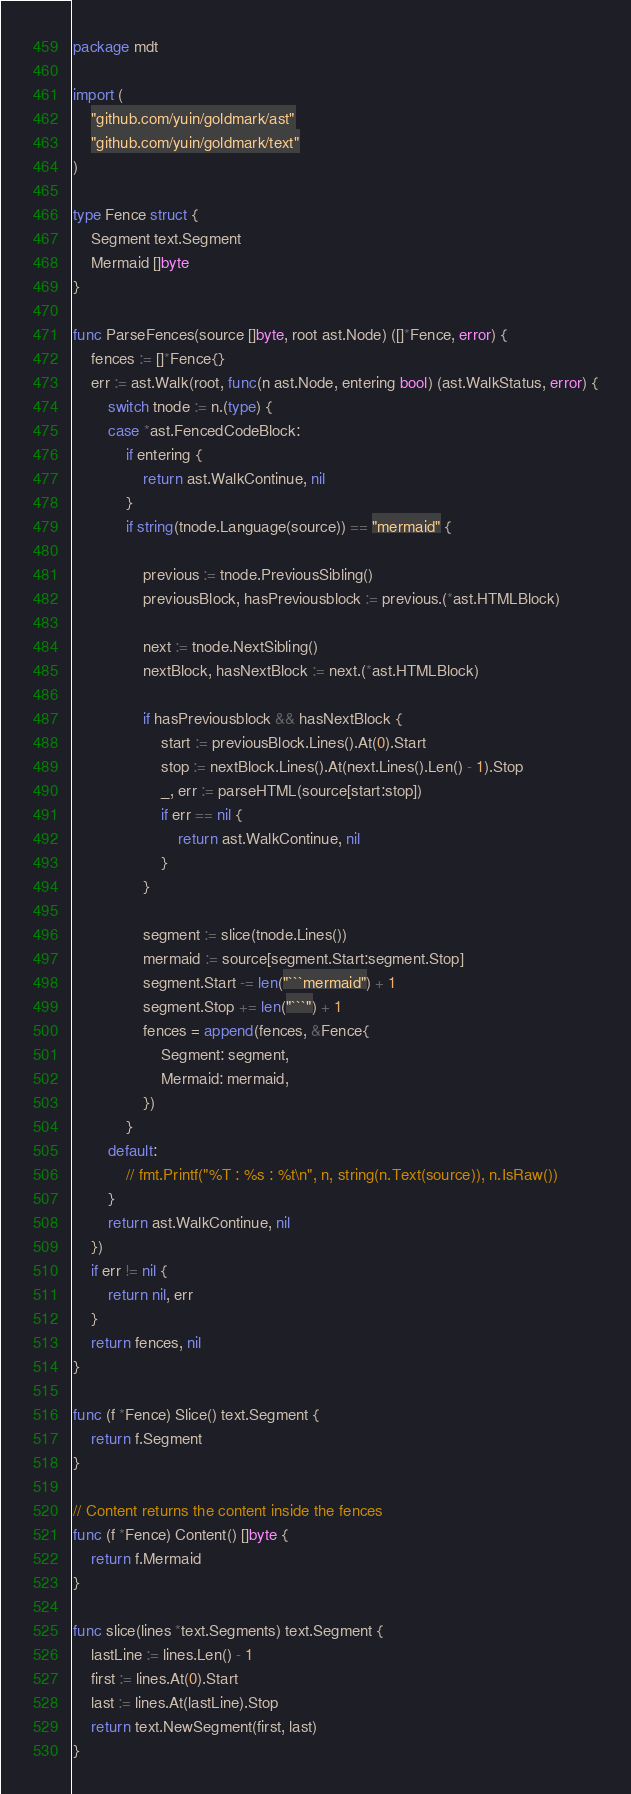Convert code to text. <code><loc_0><loc_0><loc_500><loc_500><_Go_>package mdt

import (
	"github.com/yuin/goldmark/ast"
	"github.com/yuin/goldmark/text"
)

type Fence struct {
	Segment text.Segment
	Mermaid []byte
}

func ParseFences(source []byte, root ast.Node) ([]*Fence, error) {
	fences := []*Fence{}
	err := ast.Walk(root, func(n ast.Node, entering bool) (ast.WalkStatus, error) {
		switch tnode := n.(type) {
		case *ast.FencedCodeBlock:
			if entering {
				return ast.WalkContinue, nil
			}
			if string(tnode.Language(source)) == "mermaid" {

				previous := tnode.PreviousSibling()
				previousBlock, hasPreviousblock := previous.(*ast.HTMLBlock)

				next := tnode.NextSibling()
				nextBlock, hasNextBlock := next.(*ast.HTMLBlock)

				if hasPreviousblock && hasNextBlock {
					start := previousBlock.Lines().At(0).Start
					stop := nextBlock.Lines().At(next.Lines().Len() - 1).Stop
					_, err := parseHTML(source[start:stop])
					if err == nil {
						return ast.WalkContinue, nil
					}
				}

				segment := slice(tnode.Lines())
				mermaid := source[segment.Start:segment.Stop]
				segment.Start -= len("```mermaid") + 1
				segment.Stop += len("```") + 1
				fences = append(fences, &Fence{
					Segment: segment,
					Mermaid: mermaid,
				})
			}
		default:
			// fmt.Printf("%T : %s : %t\n", n, string(n.Text(source)), n.IsRaw())
		}
		return ast.WalkContinue, nil
	})
	if err != nil {
		return nil, err
	}
	return fences, nil
}

func (f *Fence) Slice() text.Segment {
	return f.Segment
}

// Content returns the content inside the fences
func (f *Fence) Content() []byte {
	return f.Mermaid
}

func slice(lines *text.Segments) text.Segment {
	lastLine := lines.Len() - 1
	first := lines.At(0).Start
	last := lines.At(lastLine).Stop
	return text.NewSegment(first, last)
}
</code> 